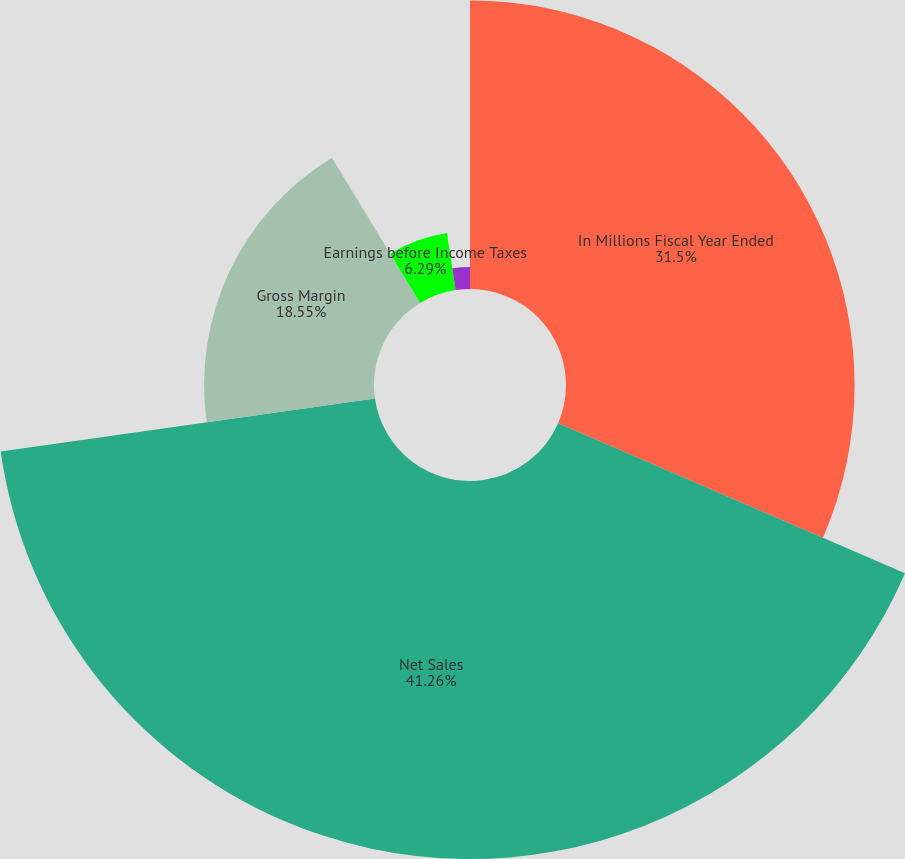Convert chart to OTSL. <chart><loc_0><loc_0><loc_500><loc_500><pie_chart><fcel>In Millions Fiscal Year Ended<fcel>Net Sales<fcel>Gross Margin<fcel>Earnings before Income Taxes<fcel>Earnings after Income Taxes<nl><fcel>31.5%<fcel>41.26%<fcel>18.55%<fcel>6.29%<fcel>2.4%<nl></chart> 